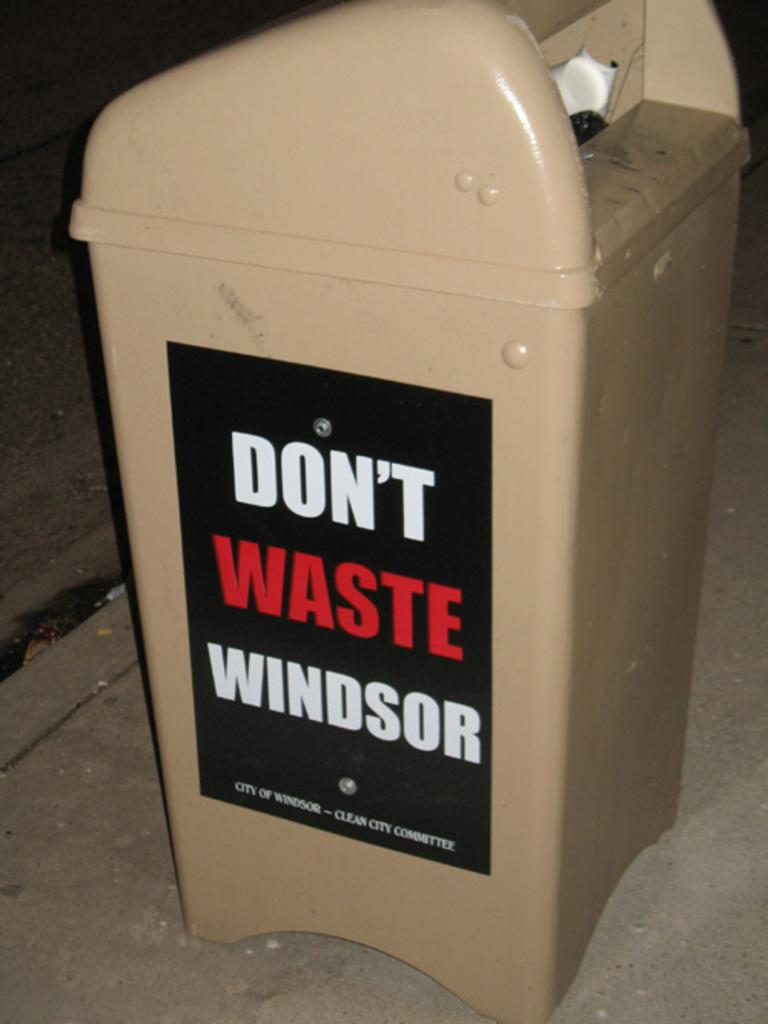<image>
Present a compact description of the photo's key features. A trash can says "don't waste Windsor" on the side. 